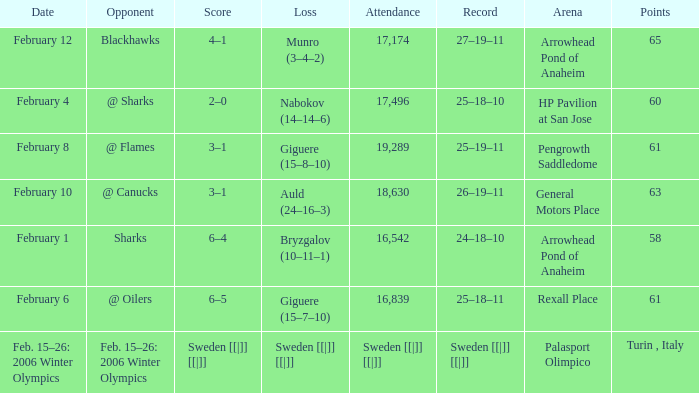What is the Arena when there were 65 points? Arrowhead Pond of Anaheim. 